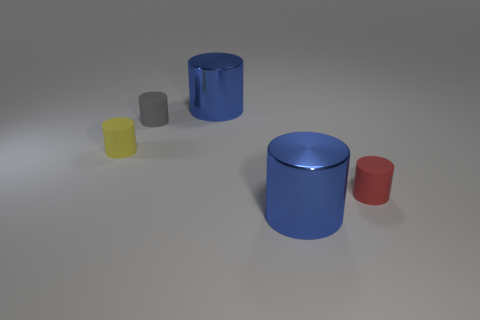Subtract 3 cylinders. How many cylinders are left? 2 Subtract all gray cylinders. How many cylinders are left? 4 Subtract all tiny red cylinders. How many cylinders are left? 4 Add 4 yellow objects. How many objects exist? 9 Subtract all cyan cylinders. Subtract all purple blocks. How many cylinders are left? 5 Add 1 yellow cylinders. How many yellow cylinders exist? 2 Subtract 0 purple blocks. How many objects are left? 5 Subtract all big blue metal things. Subtract all tiny cylinders. How many objects are left? 0 Add 3 rubber cylinders. How many rubber cylinders are left? 6 